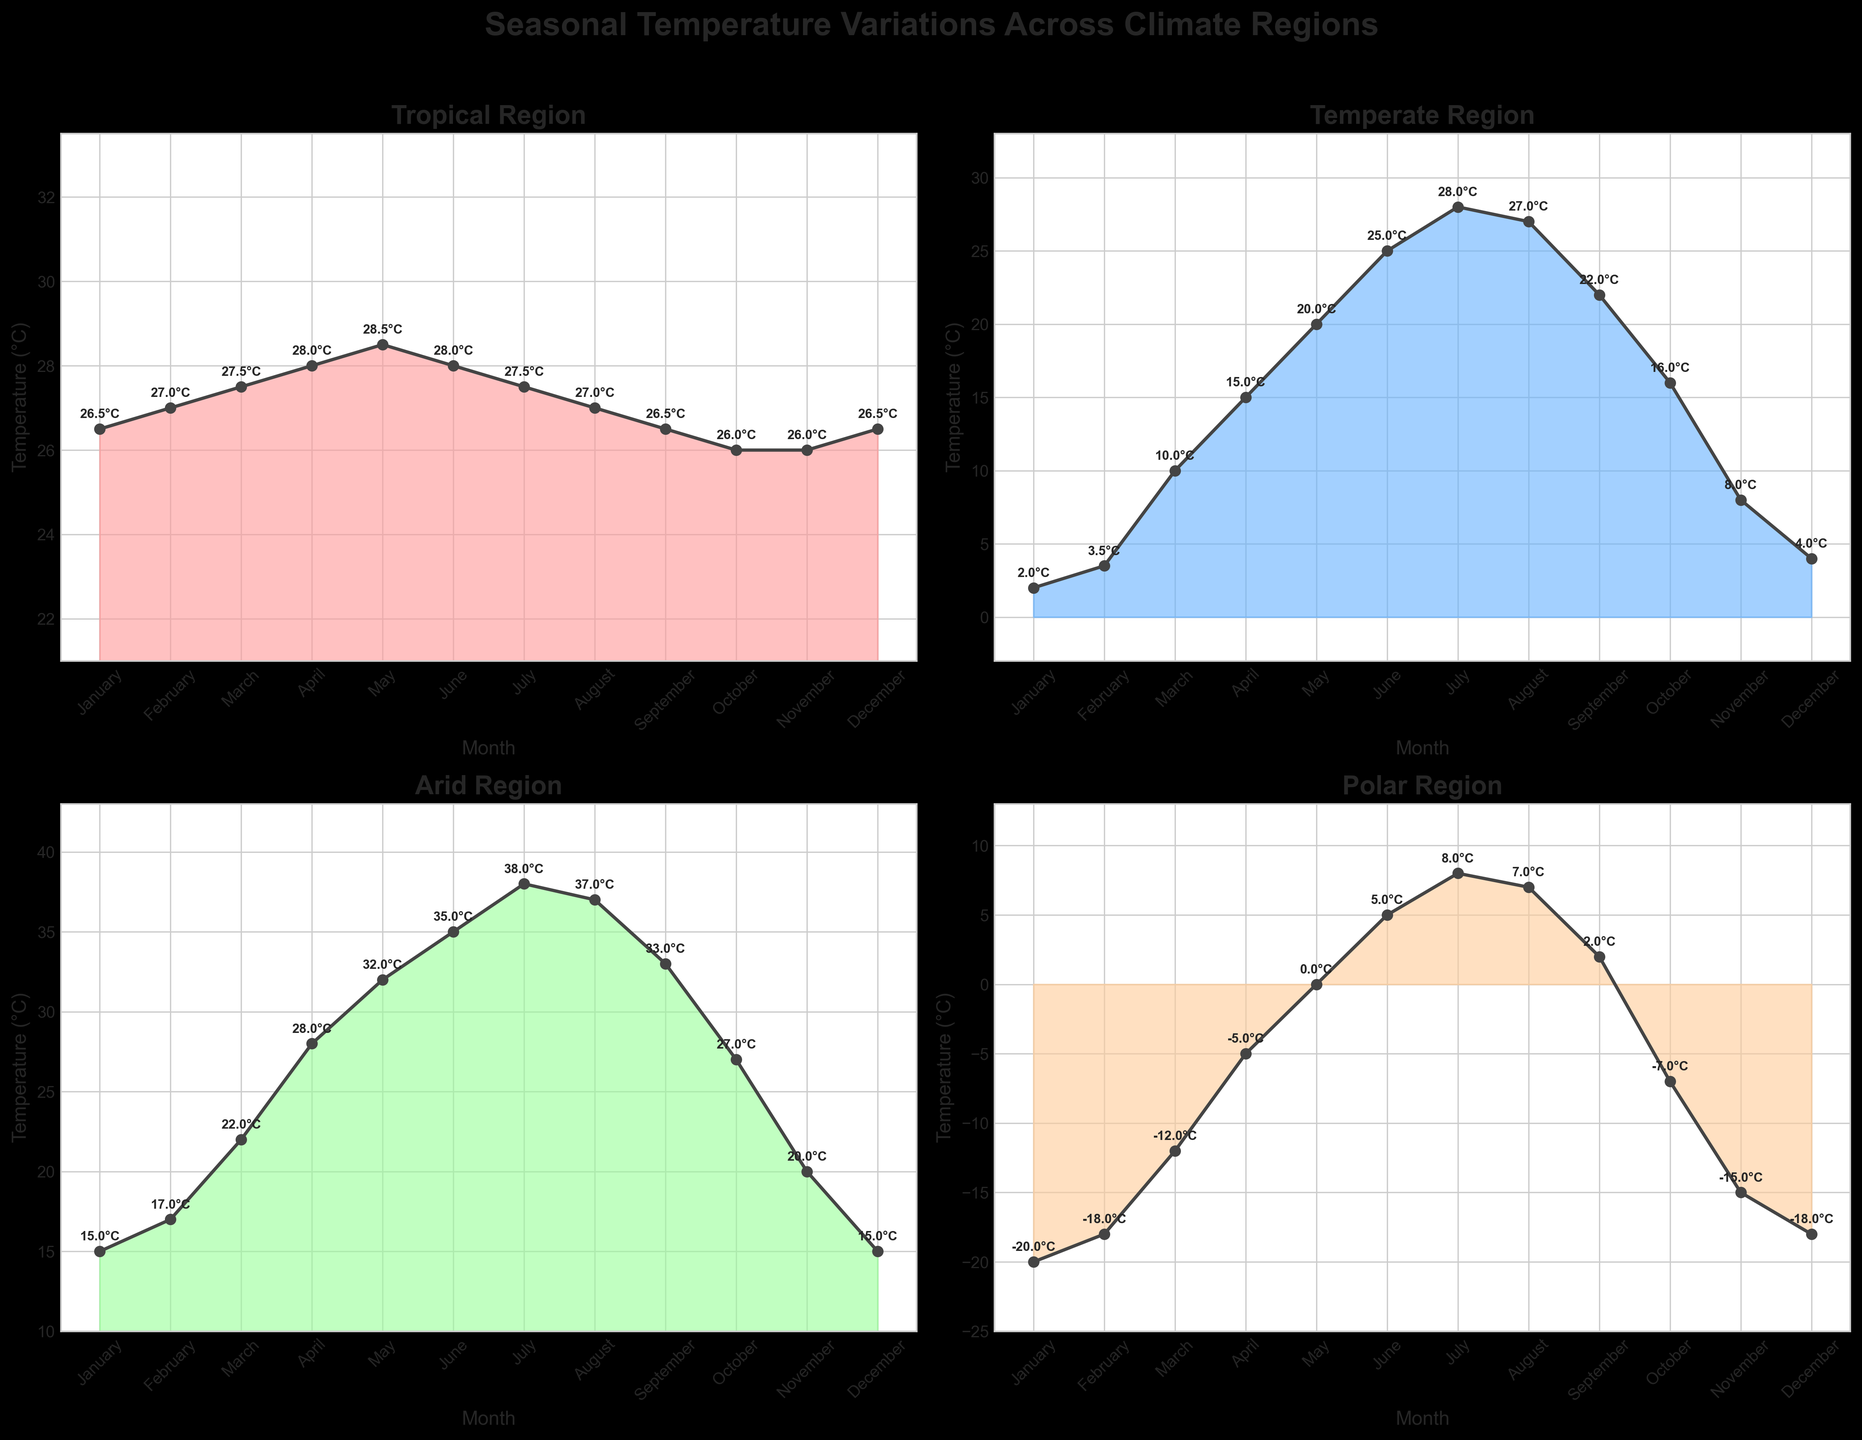What is the title of the figure? The title is usually displayed at the top of the figure. By looking at the top, the main text says "Seasonal Temperature Variations Across Climate Regions"
Answer: Seasonal Temperature Variations Across Climate Regions How many climate regions are represented in the figure? The figure contains multiple subplots, each representing a different climate region. There are four subplots/regions in total: Tropical, Temperate, Arid, and Polar
Answer: Four Which region experiences the highest temperature and in which month? By looking at the temperature peaks in each subplot, the Arid region experiences the highest temperature, with a peak of 38.0°C in July
Answer: Arid, July During which month is the temperature lowest in the Polar region? Inspecting the Polar region subplot, the minimum temperature is -20.0°C, observed in January
Answer: January In the Temperate region, what is the temperature difference between the hottest and coldest months? By finding the highest (28.0°C in July) and lowest (2.0°C in January) temperatures in the Temperate subplot, the difference is 28.0 - 2.0 = 26.0°C
Answer: 26.0°C Which climate region shows the least variation in monthly temperatures? The subplot with the smallest range between maximum and minimum temperatures indicates the least variation. The Tropical region varies between 26.0°C and 28.5°C
Answer: Tropical What is the average temperature in the Arid region for the entire year? Sum all monthly temperatures in the Arid region and divide by 12: (15+17+22+28+32+35+38+37+33+27+20+15)/12 = 26.25°C
Answer: 26.25°C How does the temperature in the Tropical region change from May to June? By observing the Tropical region subplot, the temperature decreases from 28.5°C in May to 28.0°C in June
Answer: Decreases Compare the summer (June to August) temperature patterns between the Temperate and Polar regions Temperate region temperatures rise from 25°C in June to 28°C in July and then drop to 27°C in August. In the Polar region, temperatures rise from 5°C in June to 8°C in July and then drop slightly to 7°C in August
Answer: Temperate: peaks at 28°C, Polar: peaks at 8°C What is the range of temperatures in the Temperate region for the month of October? The subplots show the Temperate region's temperature for October as being 16.0°C. The range for October would be considered the difference from October's temperature to the maximum and minimum of the year.
Answer: 16.0°C 